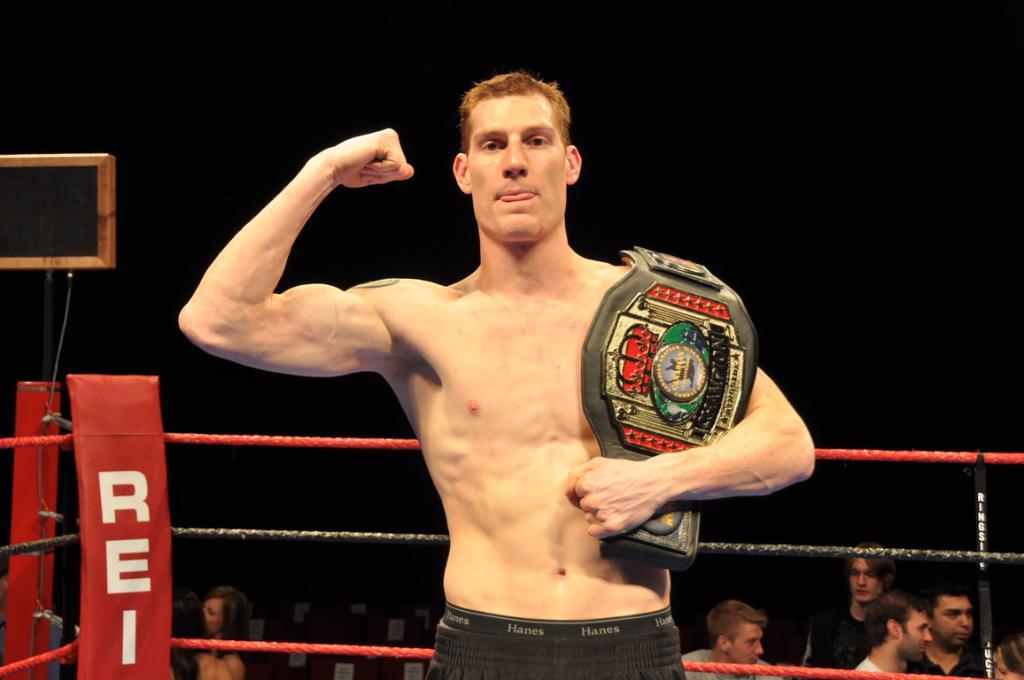What does the ring post say?
Provide a succinct answer. Rei. 